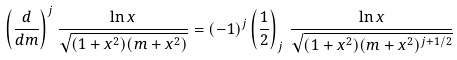<formula> <loc_0><loc_0><loc_500><loc_500>\left ( \frac { d } { d m } \right ) ^ { j } \frac { \ln x } { \sqrt { ( 1 + x ^ { 2 } ) ( m + x ^ { 2 } ) } } = ( - 1 ) ^ { j } \left ( \frac { 1 } { 2 } \right ) _ { j } \, \frac { \ln x } { \sqrt { ( 1 + x ^ { 2 } ) ( m + x ^ { 2 } ) ^ { j + 1 / 2 } } }</formula> 